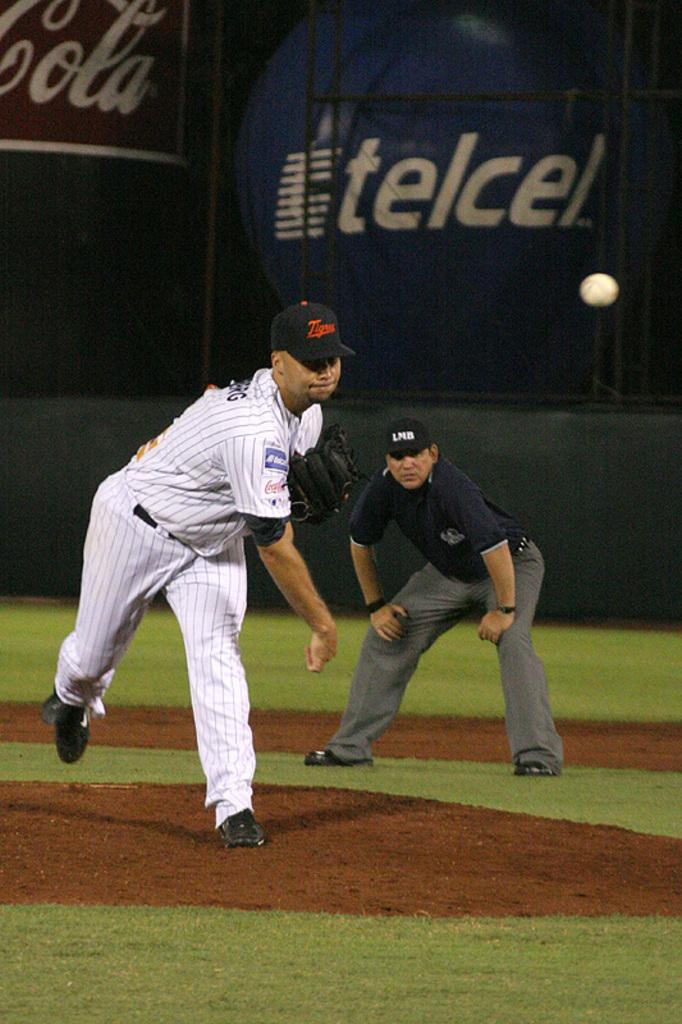<image>
Describe the image concisely. The umpire from the LMB looks on as the pitch is delivered. 